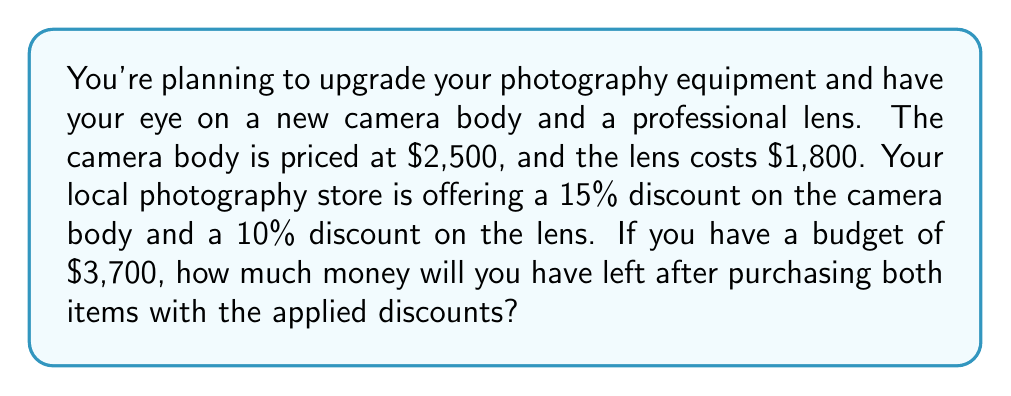Give your solution to this math problem. Let's break this problem down step by step:

1. Calculate the discounted price of the camera body:
   * Original price: $2,500
   * Discount: 15% = 0.15
   * Discount amount: $2,500 \times 0.15 = $375
   * Discounted price: $2,500 - $375 = $2,125

2. Calculate the discounted price of the lens:
   * Original price: $1,800
   * Discount: 10% = 0.10
   * Discount amount: $1,800 \times 0.10 = $180
   * Discounted price: $1,800 - $180 = $1,620

3. Calculate the total cost of both items after discounts:
   * Total cost = Discounted camera body + Discounted lens
   * Total cost = $2,125 + $1,620 = $3,745

4. Calculate the remaining money from the budget:
   * Budget: $3,700
   * Remaining money = Budget - Total cost
   * Remaining money = $3,700 - $3,745 = -$45

The negative result indicates that the purchases exceed the budget by $45.
Answer: You will not have any money left after purchasing both items. In fact, you will be $45 over your budget. 